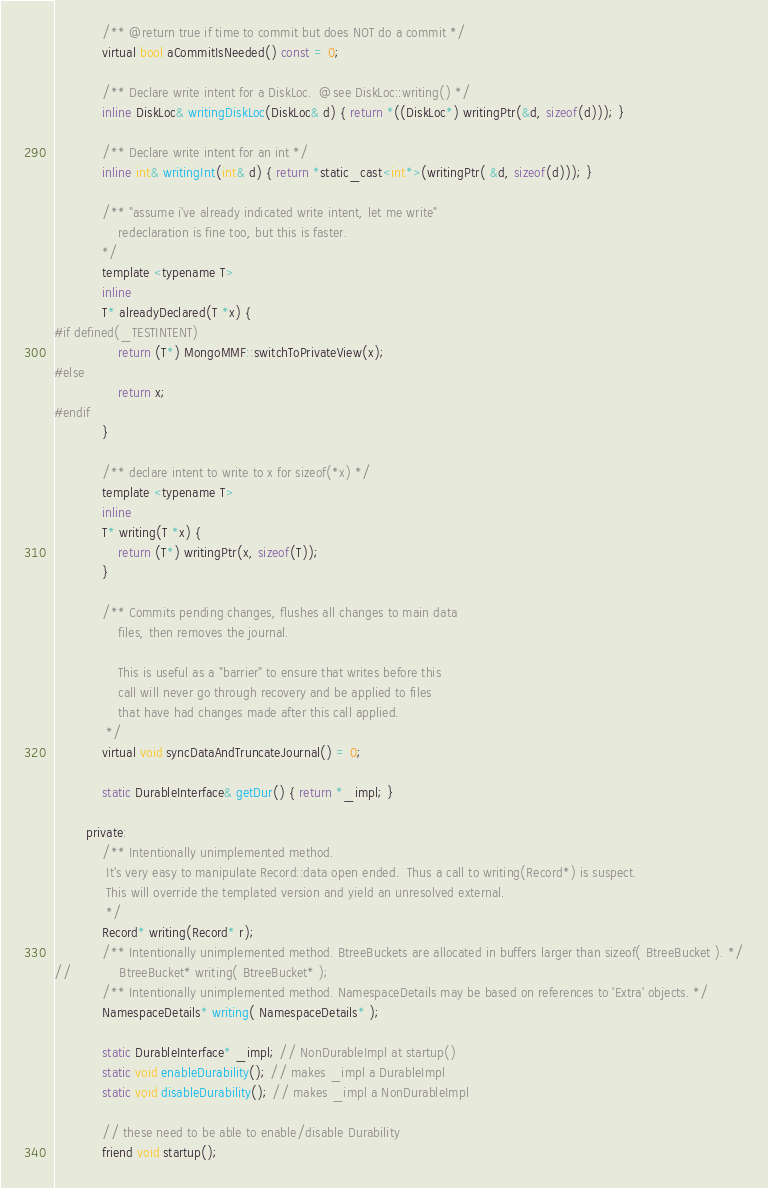Convert code to text. <code><loc_0><loc_0><loc_500><loc_500><_C_>            /** @return true if time to commit but does NOT do a commit */
            virtual bool aCommitIsNeeded() const = 0;

            /** Declare write intent for a DiskLoc.  @see DiskLoc::writing() */
            inline DiskLoc& writingDiskLoc(DiskLoc& d) { return *((DiskLoc*) writingPtr(&d, sizeof(d))); }

            /** Declare write intent for an int */
            inline int& writingInt(int& d) { return *static_cast<int*>(writingPtr( &d, sizeof(d))); }

            /** "assume i've already indicated write intent, let me write"
                redeclaration is fine too, but this is faster.
            */
            template <typename T>
            inline
            T* alreadyDeclared(T *x) {
#if defined(_TESTINTENT)
                return (T*) MongoMMF::switchToPrivateView(x);
#else
                return x;
#endif
            }

            /** declare intent to write to x for sizeof(*x) */
            template <typename T>
            inline
            T* writing(T *x) {
                return (T*) writingPtr(x, sizeof(T));
            }

            /** Commits pending changes, flushes all changes to main data
                files, then removes the journal.
                
                This is useful as a "barrier" to ensure that writes before this
                call will never go through recovery and be applied to files
                that have had changes made after this call applied.
             */
            virtual void syncDataAndTruncateJournal() = 0;

            static DurableInterface& getDur() { return *_impl; }

        private:
            /** Intentionally unimplemented method.
             It's very easy to manipulate Record::data open ended.  Thus a call to writing(Record*) is suspect.
             This will override the templated version and yield an unresolved external.
             */
            Record* writing(Record* r);
            /** Intentionally unimplemented method. BtreeBuckets are allocated in buffers larger than sizeof( BtreeBucket ). */
//            BtreeBucket* writing( BtreeBucket* );
            /** Intentionally unimplemented method. NamespaceDetails may be based on references to 'Extra' objects. */
            NamespaceDetails* writing( NamespaceDetails* );

            static DurableInterface* _impl; // NonDurableImpl at startup()
            static void enableDurability(); // makes _impl a DurableImpl
            static void disableDurability(); // makes _impl a NonDurableImpl

            // these need to be able to enable/disable Durability
            friend void startup();</code> 